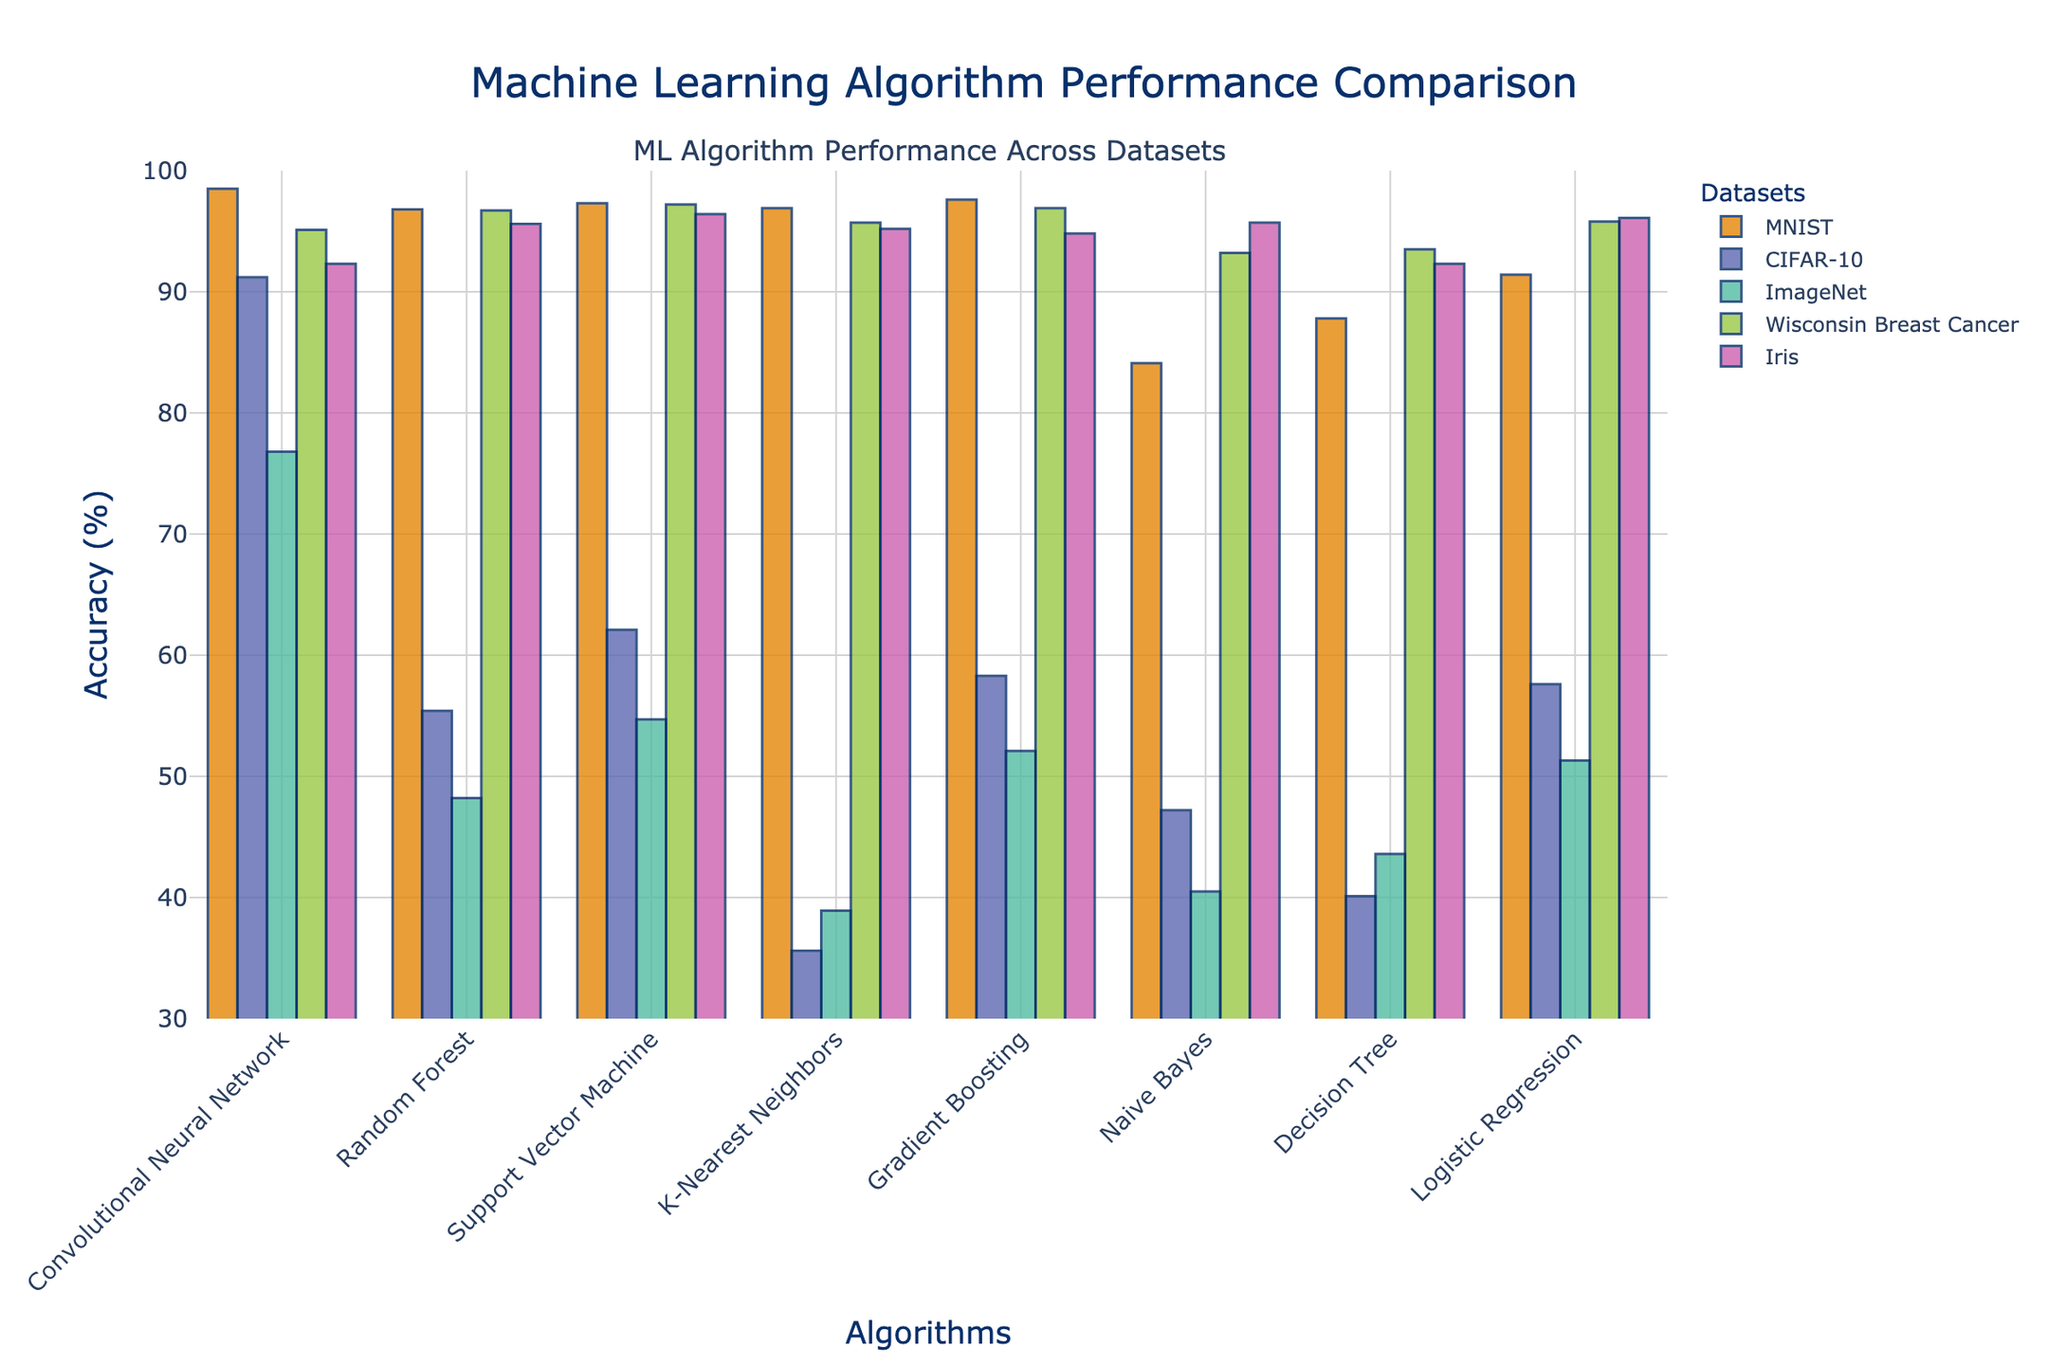What is the highest accuracy achieved for the MNIST dataset? Look at the bars corresponding to the MNIST dataset. The highest bar represents the highest accuracy value. In this case, it is the Convolutional Neural Network with 98.5%.
Answer: 98.5% Which algorithm performs the worst on the CIFAR-10 dataset? Observe the bars related to the CIFAR-10 dataset. The shortest bar indicates the worst performance. Here, K-Nearest Neighbors has the lowest value with 35.6%.
Answer: K-Nearest Neighbors Between Random Forest and Gradient Boosting, which algorithm performs better on the Wisconsin Breast Cancer dataset and by how much? Compare the height of the bars for Random Forest and Gradient Boosting in the Wisconsin Breast Cancer dataset. Random Forest has an accuracy of 96.7% and Gradient Boosting has 96.9%. The difference is 96.9% - 96.7% = 0.2%.
Answer: Gradient Boosting, 0.2% Which algorithm achieves the highest accuracy on the Iris dataset? Identify the tallest bar in the Iris dataset section. Support Vector Machine achieves the highest accuracy with 96.4%.
Answer: Support Vector Machine For the ImageNet dataset, what is the difference in accuracy between Convolutional Neural Network and Naive Bayes? Subtract the accuracy of Naive Bayes (40.5%) from that of Convolutional Neural Network (76.8%). The difference is 76.8% - 40.5% = 36.3%.
Answer: 36.3% What is the average accuracy of Logistic Regression across all datasets? Sum the accuracies of Logistic Regression for all datasets and divide by the number of datasets: (91.4 + 57.6 + 51.3 + 95.8 + 96.1) / 5 = 78.44%.
Answer: 78.44% Which dataset shows the most variation in algorithm performance? Compare the range (difference between highest and lowest accuracies) of each dataset. CIFAR-10 has the most variation, from Naive Bayes (47.2%) to Convolutional Neural Network (91.2%), which is a difference of 44.0%.
Answer: CIFAR-10 Which two algorithms have the closest performance on the MNIST dataset? Compare the bars for the MNIST dataset, identifying the pairs with the smallest difference. K-Nearest Neighbors (96.9%) and Random Forest (96.8%) have the closest performance with a difference of 0.1%.
Answer: K-Nearest Neighbors and Random Forest How does the performance of Decision Tree compare between the Iris and ImageNet datasets? Check the bars for Decision Tree in both datasets. For Iris, the accuracy is 92.3%, while for ImageNet, it is 43.6%.
Answer: Decision Tree performs better on the Iris dataset 